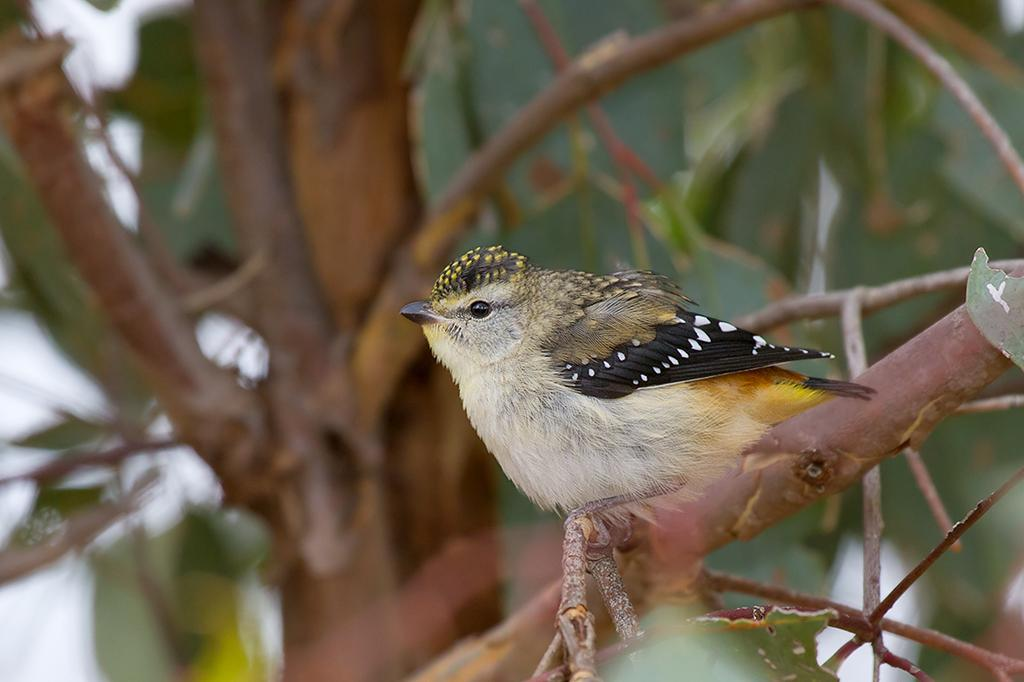What type of animal can be seen in the image? There is a bird in the image. Where is the bird located? The bird is on a tree. What type of metal can be seen in the image? There is no metal present in the image; it features a bird on a tree. Are there any fairies visible in the image? There are no fairies present in the image; it features a bird on a tree. 